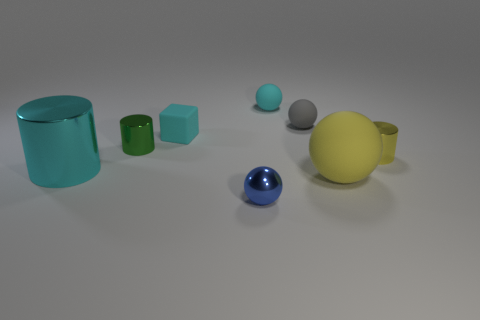Subtract 1 spheres. How many spheres are left? 3 Add 1 gray matte things. How many objects exist? 9 Subtract all cylinders. How many objects are left? 5 Subtract 0 purple blocks. How many objects are left? 8 Subtract all tiny yellow matte cylinders. Subtract all blue objects. How many objects are left? 7 Add 5 cyan shiny things. How many cyan shiny things are left? 6 Add 3 large yellow rubber spheres. How many large yellow rubber spheres exist? 4 